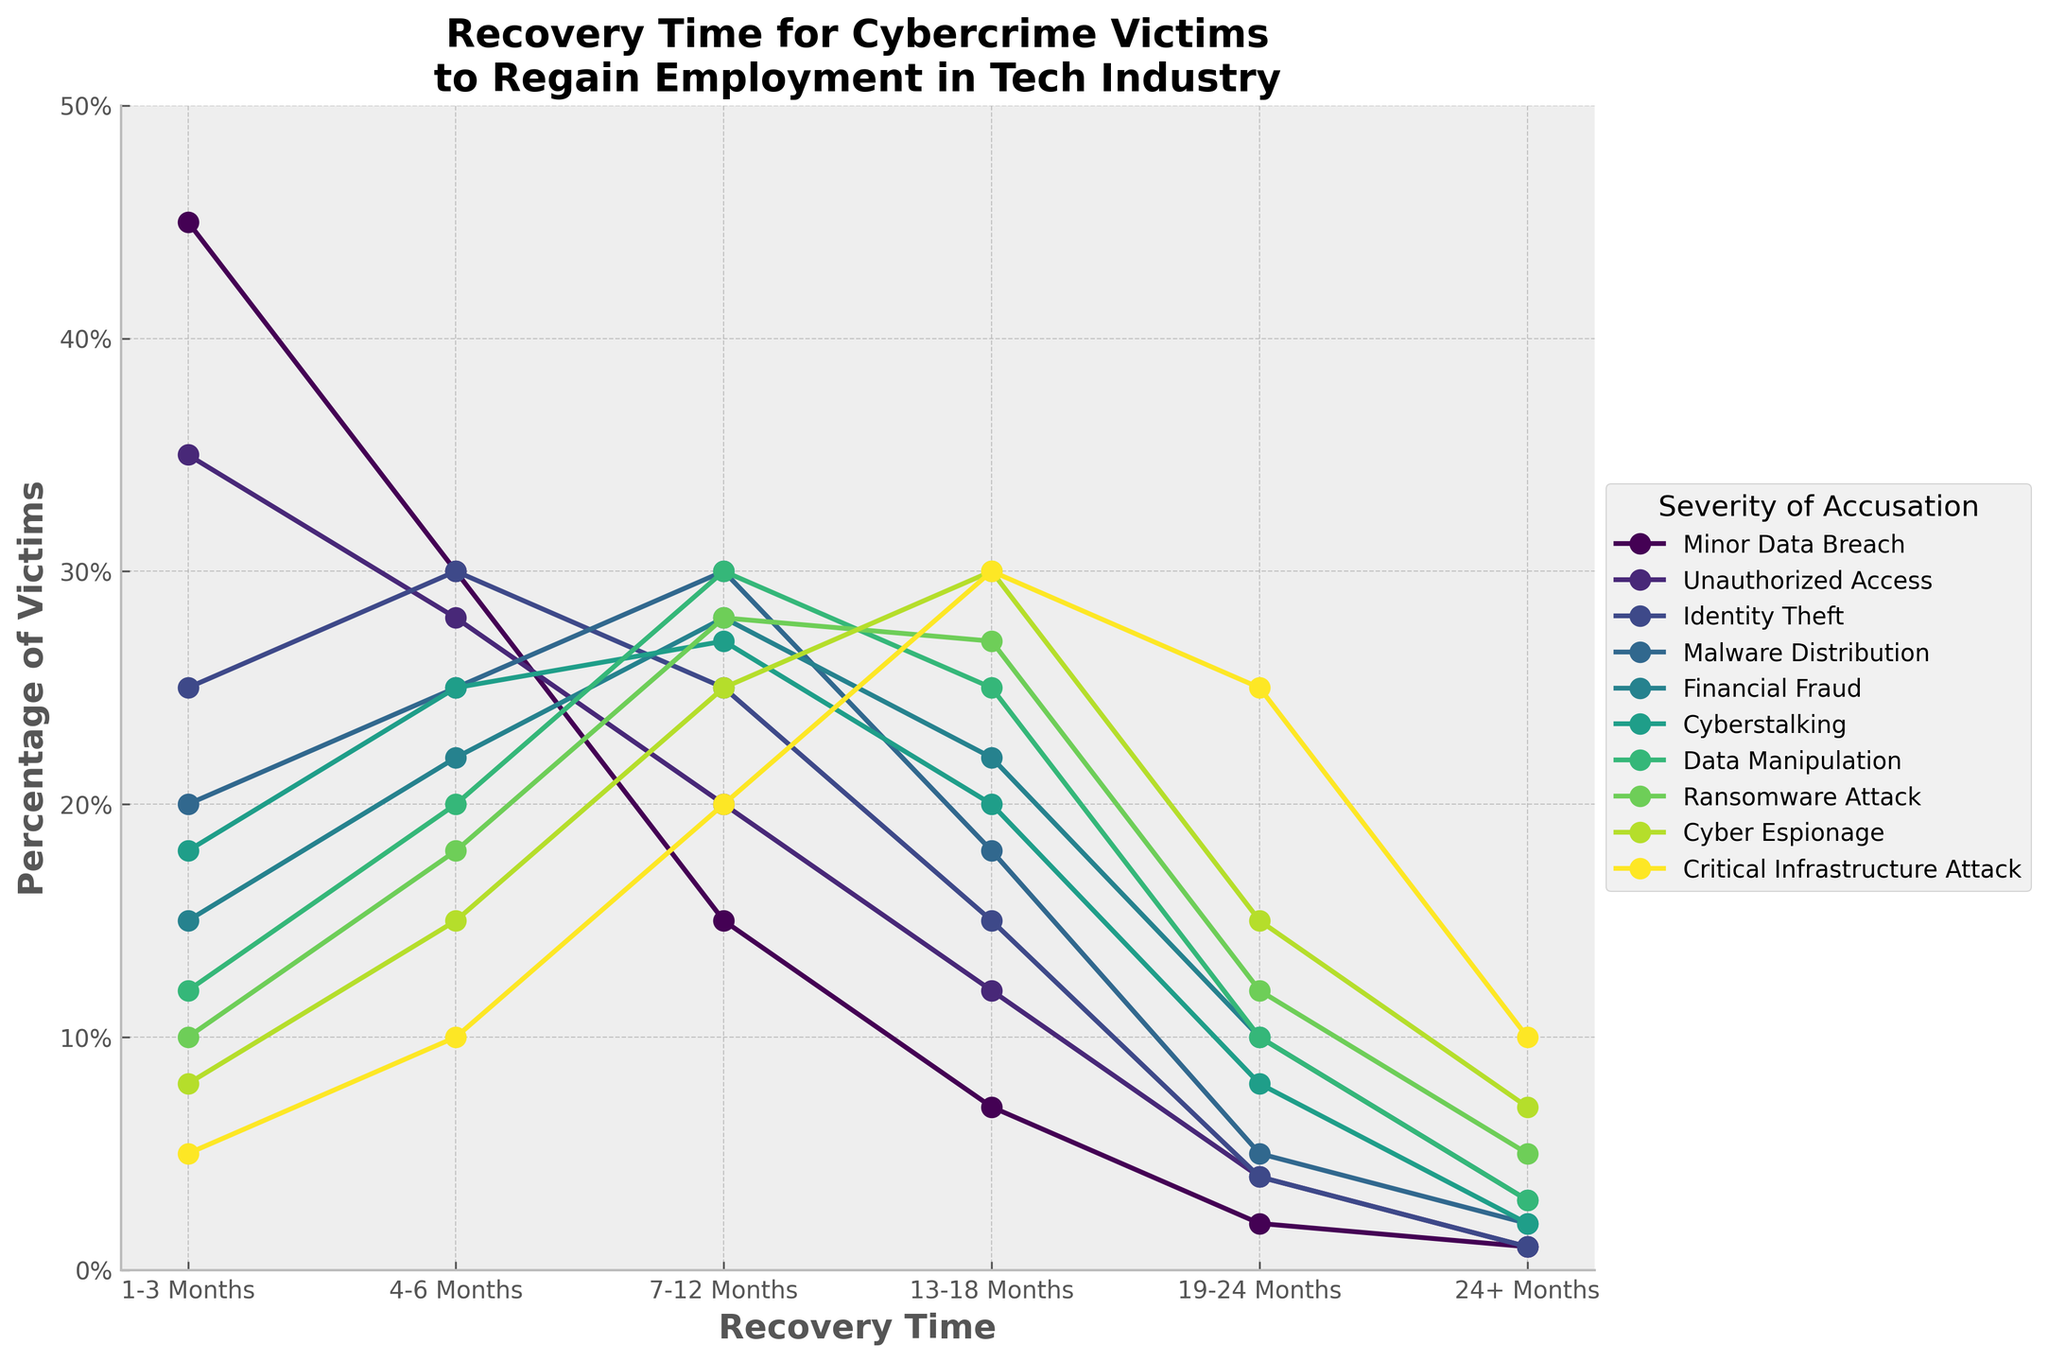How many months did it take the largest percentage of victims to regain employment after a Minor Data Breach? The largest percentage for Minor Data Breach is the highest point on the line for this category. The highest percentage is 45% at the 1-3 months period.
Answer: 1-3 months Which type of accusation has the highest percentage of victims recovering in the 19-24 months period? To find the highest percentage in the 19-24 months period, we need to compare all values in that column. The highest value is 25% for Critical Infrastructure Attack.
Answer: Critical Infrastructure Attack What is the combined percentage of Data Manipulation victims who took more than 12 months to regain employment? Add the values for Data Manipulation in the 13-18 months (25%), 19-24 months (10%), and 24+ months (3%) periods. 25% + 10% + 3% = 38%.
Answer: 38% Which accusation has a steeper initial decline in recovery rate from 1-3 months to 4-6 months? By visually comparing the slopes of the lines from 1-3 months to 4-6 months, the steepest decline is seen for Minor Data Breach, where the percentage drops from 45% to 30%.
Answer: Minor Data Breach Between Cyber Espionage and Ransomware Attack, which has a higher percentage of victims recovering in the 13-18 months period? Check the percentage values for both severity types at the 13-18 months mark. Cyber Espionage has 30% and Ransomware Attack has 27%.
Answer: Cyber Espionage What is the difference in the percentage recovery rate between Identity Theft and Financial Fraud in the 7-12 months period? Subtract the percentage for Financial Fraud (28%) from Identity Theft (25%). 28% - 25% = 3%.
Answer: 3% Which accusation has the smallest percentage of victims recovering in the 1-3 months period? Identify the smallest percentage in the 1-3 months column. The smallest value is 5% for Critical Infrastructure Attack.
Answer: Critical Infrastructure Attack How many severity types have a percentage of 20% or higher recovery in the 4-6 months period? Count all instances where the percentage is 20% or higher in the 4-6 months column. There are 10 severity types that meet this criterion.
Answer: 10 What's the average recovery rate for Cyberstalking victims from 1-18 months? Calculate the average of the percentages for Cyberstalking from 1-3 months (18%), 4-6 months (25%), 7-12 months (27%), and 13-18 months (20%). (18 + 25 + 27 + 20) / 4 = 22.5%.
Answer: 22.5% Compare the recovery rates after 24+ months for Ransomware Attack to Minor Data Breach. Which is higher and by how much? Subtract Minor Data Breach's 24+ months rate (1%) from Ransomware Attack (5%). 5% - 1% = 4%.
Answer: Ransomware Attack by 4% 